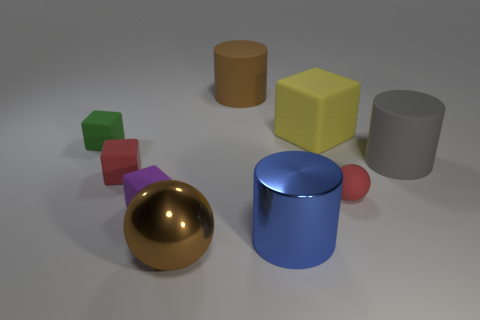Is the number of matte cubes that are behind the green rubber cube greater than the number of cyan metal balls?
Offer a very short reply. Yes. What number of green cubes are the same size as the blue thing?
Ensure brevity in your answer.  0. There is a sphere that is behind the purple cube; does it have the same size as the cylinder on the right side of the blue metallic object?
Your response must be concise. No. What is the size of the matte cylinder in front of the green cube?
Offer a very short reply. Large. There is a block to the left of the tiny red object on the left side of the brown rubber object; what is its size?
Offer a terse response. Small. What material is the yellow thing that is the same size as the blue metal object?
Provide a short and direct response. Rubber. Are there any metal cylinders left of the small matte sphere?
Offer a very short reply. Yes. Is the number of small rubber things that are right of the large shiny sphere the same as the number of small yellow matte things?
Give a very brief answer. No. There is a blue thing that is the same size as the yellow matte object; what is its shape?
Your answer should be compact. Cylinder. What material is the big brown ball?
Give a very brief answer. Metal. 